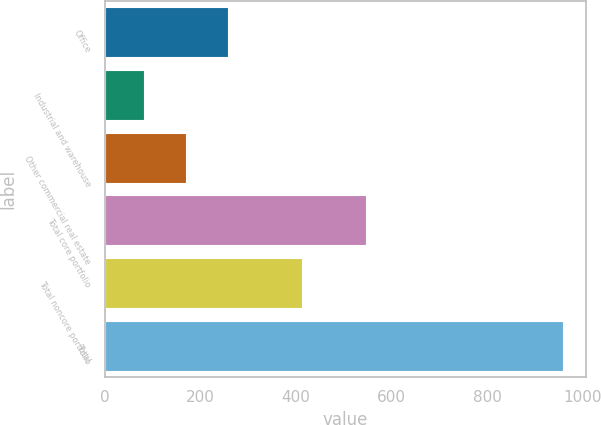Convert chart. <chart><loc_0><loc_0><loc_500><loc_500><bar_chart><fcel>Office<fcel>Industrial and warehouse<fcel>Other commercial real estate<fcel>Total core portfolio<fcel>Total noncore portfolio<fcel>Total<nl><fcel>256.6<fcel>81<fcel>168.8<fcel>547<fcel>412<fcel>959<nl></chart> 